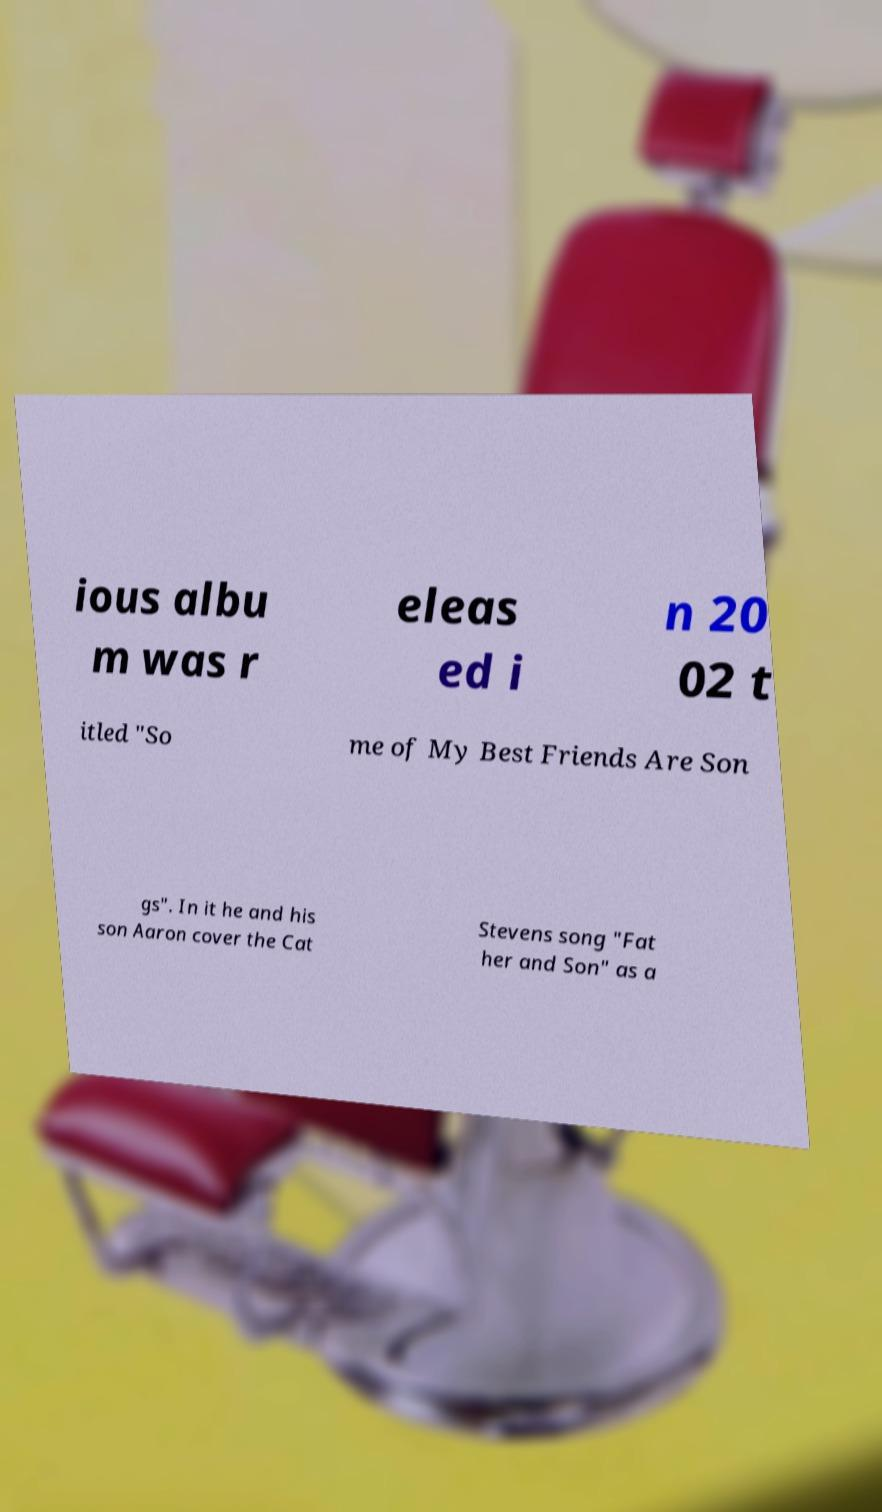I need the written content from this picture converted into text. Can you do that? ious albu m was r eleas ed i n 20 02 t itled "So me of My Best Friends Are Son gs". In it he and his son Aaron cover the Cat Stevens song "Fat her and Son" as a 